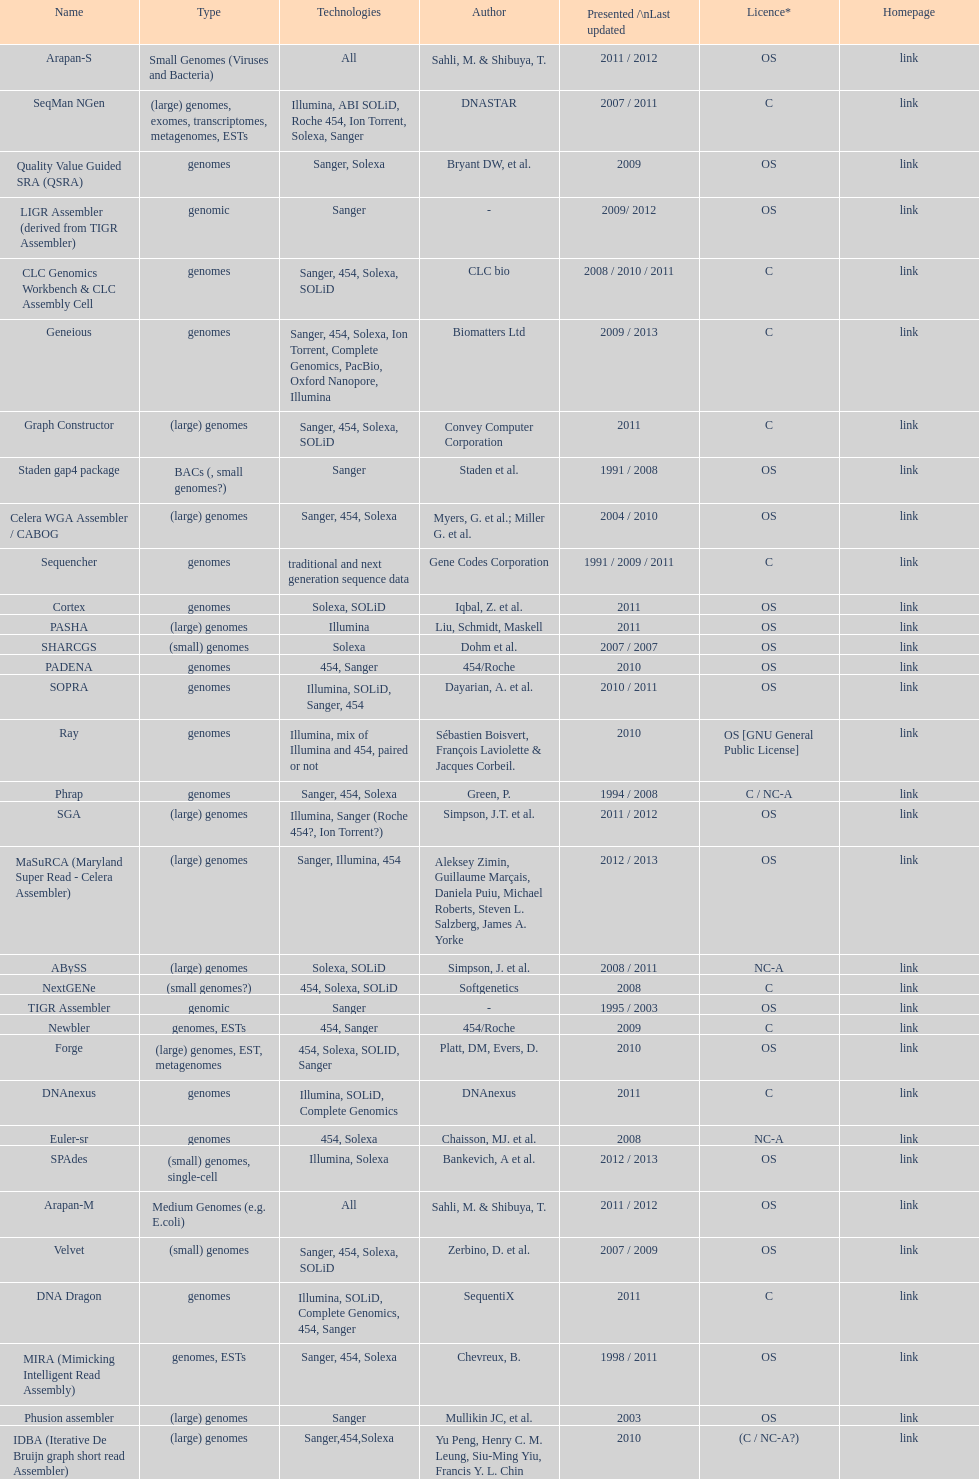When was the velvet last updated? 2009. 